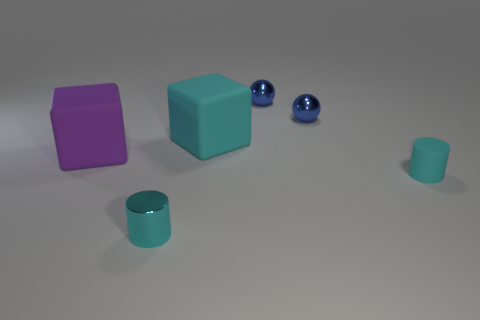Subtract all cyan blocks. How many blocks are left? 1 Add 3 green shiny cylinders. How many objects exist? 9 Subtract all cylinders. How many objects are left? 4 Subtract 1 cylinders. How many cylinders are left? 1 Subtract all small rubber objects. Subtract all purple cubes. How many objects are left? 4 Add 5 large objects. How many large objects are left? 7 Add 1 cyan cubes. How many cyan cubes exist? 2 Subtract 0 red cylinders. How many objects are left? 6 Subtract all red cylinders. Subtract all red spheres. How many cylinders are left? 2 